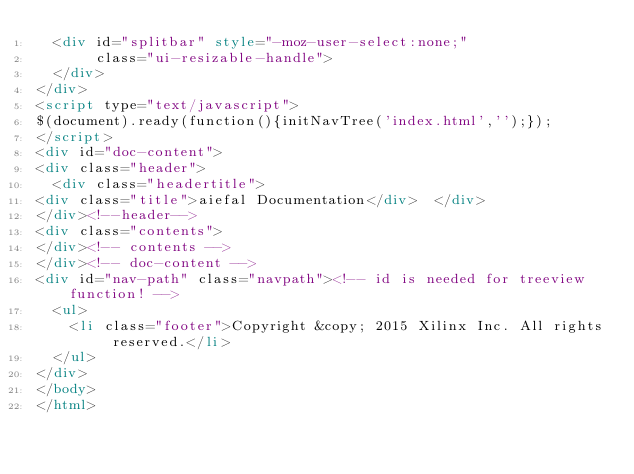<code> <loc_0><loc_0><loc_500><loc_500><_HTML_>  <div id="splitbar" style="-moz-user-select:none;" 
       class="ui-resizable-handle">
  </div>
</div>
<script type="text/javascript">
$(document).ready(function(){initNavTree('index.html','');});
</script>
<div id="doc-content">
<div class="header">
  <div class="headertitle">
<div class="title">aiefal Documentation</div>  </div>
</div><!--header-->
<div class="contents">
</div><!-- contents -->
</div><!-- doc-content -->
<div id="nav-path" class="navpath"><!-- id is needed for treeview function! -->
  <ul>
    <li class="footer">Copyright &copy; 2015 Xilinx Inc. All rights reserved.</li>
  </ul>
</div>
</body>
</html>
</code> 